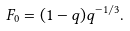<formula> <loc_0><loc_0><loc_500><loc_500>F _ { 0 } = ( 1 - q ) q ^ { - 1 / 3 } .</formula> 